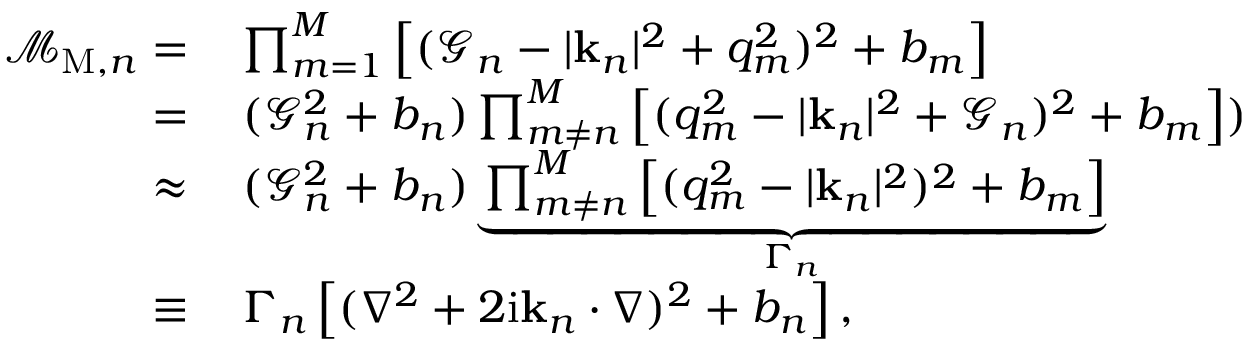Convert formula to latex. <formula><loc_0><loc_0><loc_500><loc_500>\begin{array} { r l } { \mathcal { M } _ { M , n } = } & \prod _ { m = 1 } ^ { M } \left [ ( \mathcal { G } _ { n } - | k _ { n } | ^ { 2 } + q _ { m } ^ { 2 } ) ^ { 2 } + b _ { m } \right ] } \\ { = } & \, ( \mathcal { G } _ { n } ^ { 2 } + b _ { n } ) \prod _ { m \neq n } ^ { M } \left [ ( q _ { m } ^ { 2 } - | k _ { n } | ^ { 2 } + \mathcal { G } _ { n } ) ^ { 2 } + b _ { m } \right ] ) } \\ { \approx } & \, ( \mathcal { G } _ { n } ^ { 2 } + b _ { n } ) \underbrace { \prod _ { m \neq n } ^ { M } \left [ ( q _ { m } ^ { 2 } - | k _ { n } | ^ { 2 } ) ^ { 2 } + b _ { m } \right ] } _ { \Gamma _ { n } } } \\ { \equiv } & \, \Gamma _ { n } \left [ ( \nabla ^ { 2 } + 2 i k _ { n } \cdot \nabla ) ^ { 2 } + b _ { n } \right ] , } \end{array}</formula> 